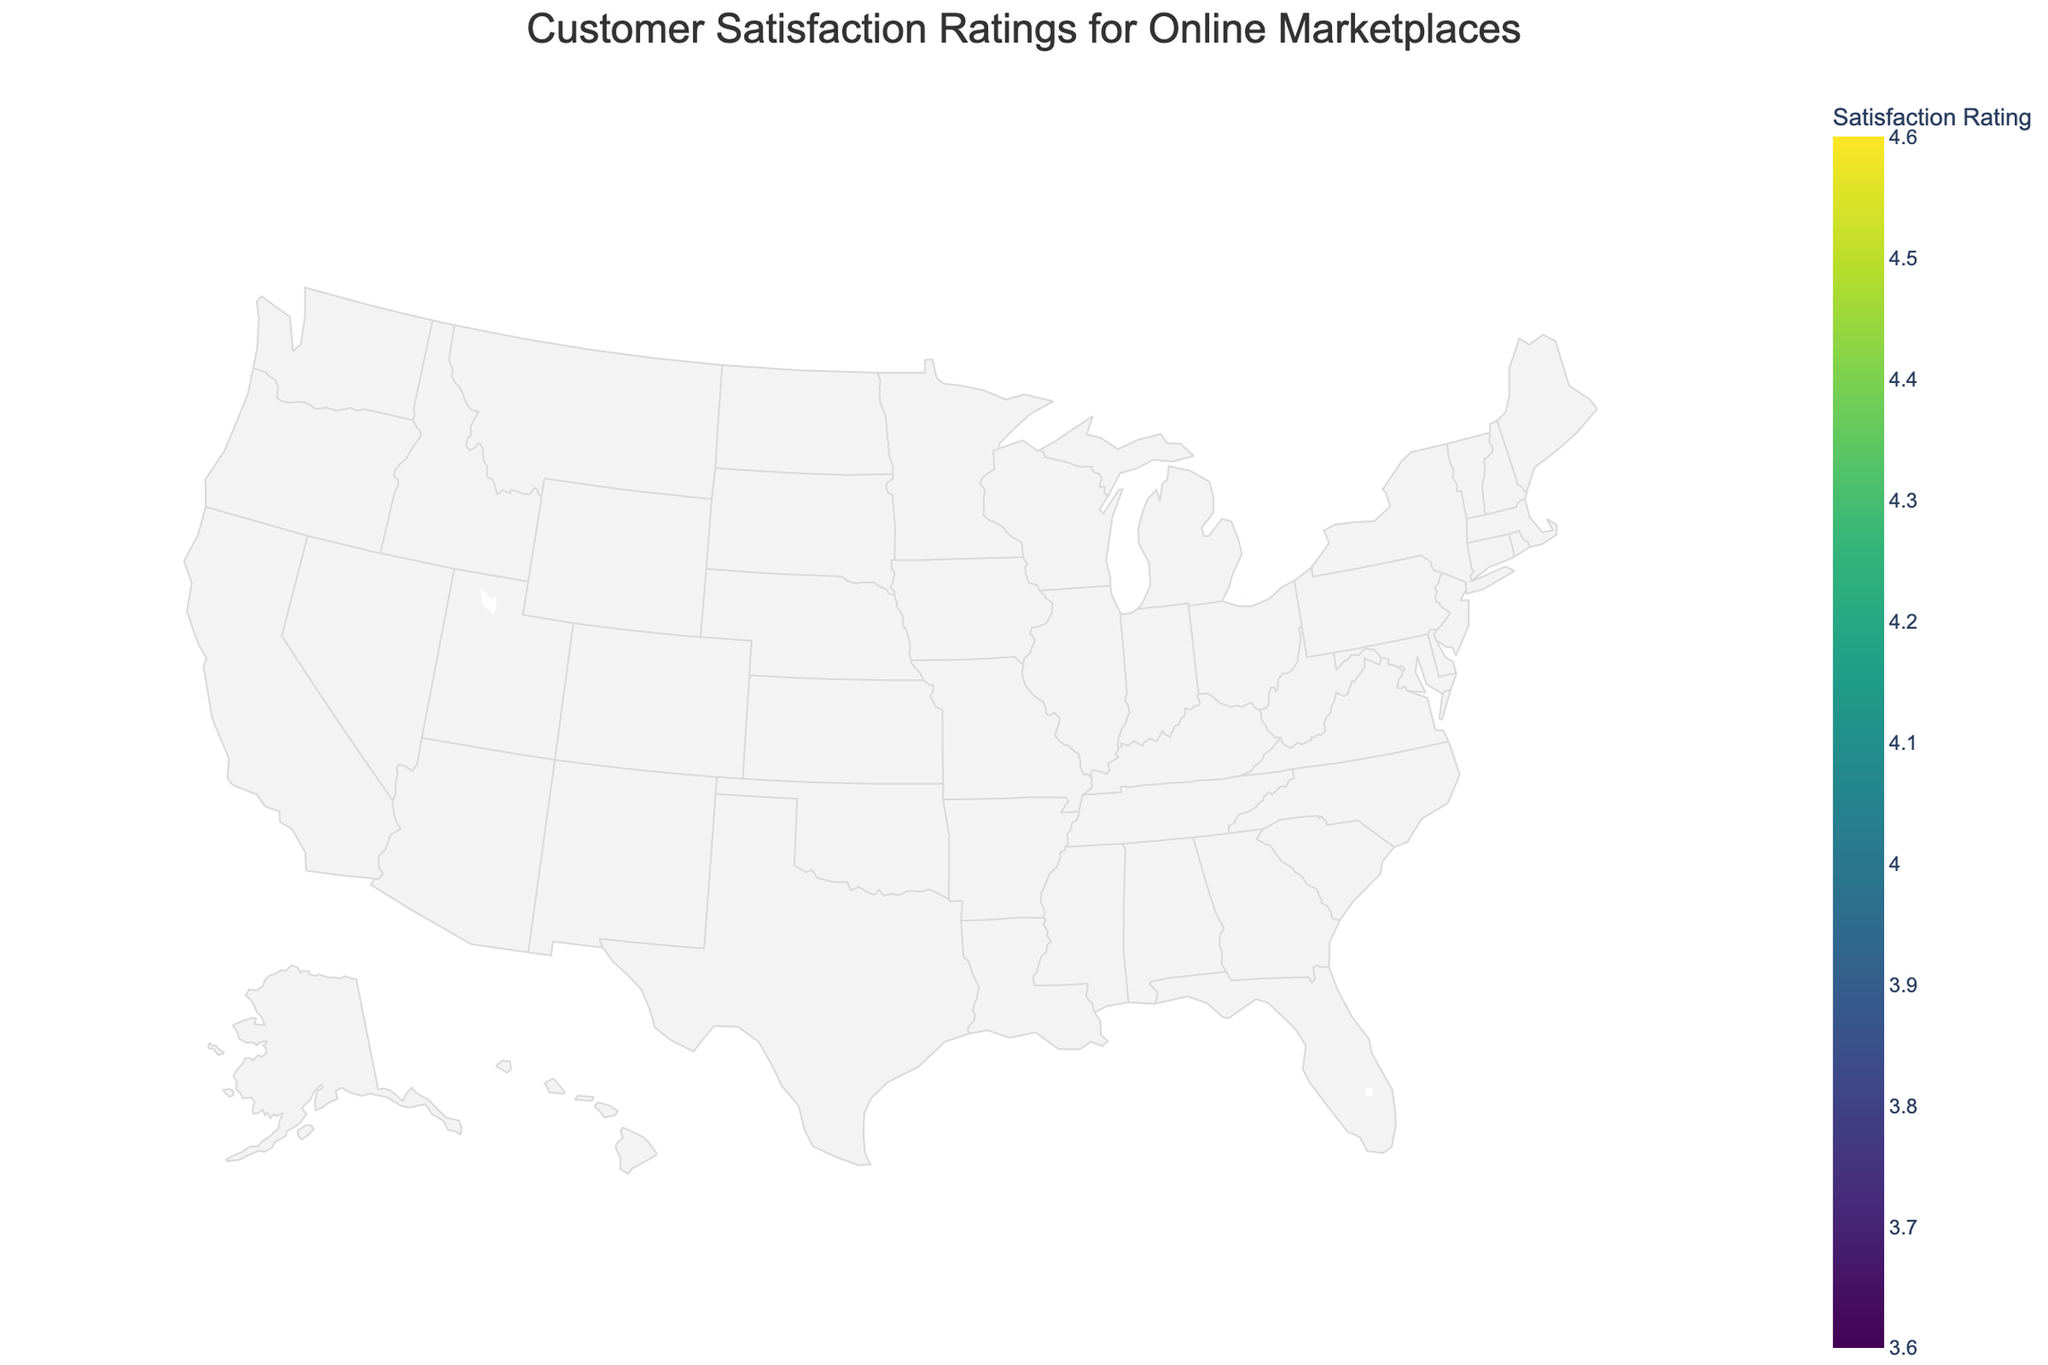what is the highest customer satisfaction rating in the Northeast region? Look for data points in the Northeast region and check their satisfaction ratings. The highest rating is Etsy with a rating of 4.5 in Handmade Goods.
Answer: 4.5 What kind of product category has the highest satisfaction rating in the South region? Look at the South region and identify the highest rating. The highest rating is 4.6 for Pet Supplies on Chewy.
Answer: Pet Supplies Which region has the lowest satisfaction rating? Compare the lowest satisfaction ratings across all regions. The lowest rating is from the Northwest region with Walmart at 3.6 for Office Supplies.
Answer: Northwest How does Amazon's rating for books in the South compare to Walmart's rating for groceries in the Midwest? Check the satisfaction rating for Amazon's books in the South (4.4) and Walmart's groceries in the Midwest (3.7). Amazon's rating for books in the South is higher than Walmart's for groceries in the Midwest.
Answer: Higher What is the average satisfaction rating for Amazon across all regions? Calculate the average rating of Amazon's products across different regions: (4.2 + 4.3 + 4.4 + 4.1 + 4.0) / 5. The sum is 21.0, and the average is 21.0 / 5 = 4.2.
Answer: 4.2 Which marketplace has the highest satisfaction rating for Kitchen Appliances? Look at the Kitchen Appliances category and check the corresponding marketplace. Amazon in the Northwest has a rating of 4.0.
Answer: Amazon Is there a region where Walmart's satisfaction rating is higher than 4.0? Check Walmart's ratings in all regions: Northeast (3.8), Midwest (3.7), South (3.9), West (3.8), Northwest (3.6). None of these is higher than 4.0.
Answer: No How many regions have Amazon as the highest-rated marketplace for any product category? Count the regions where Amazon has the top satisfaction rating: Northeast (Electronics 4.2), Midwest (Toys & Games 4.3), South (Books 4.4), West (Beauty & Personal Care 4.1), Northwest (Kitchen Appliances 4.0). The total count is 5.
Answer: 5 Which region has a marketplace with a satisfaction rating above 4.5? Check each region for ratings above 4.5. The South region has Chewy with 4.6 for Pet Supplies.
Answer: South How does the satisfaction rating for Best Buy in the Northwest compare to Overstock in the Midwest? Check the satisfaction rating for Best Buy in the Northwest (4.1) and Overstock in the Midwest (4.0). Best Buy in the Northwest has a slightly higher rating.
Answer: Higher 